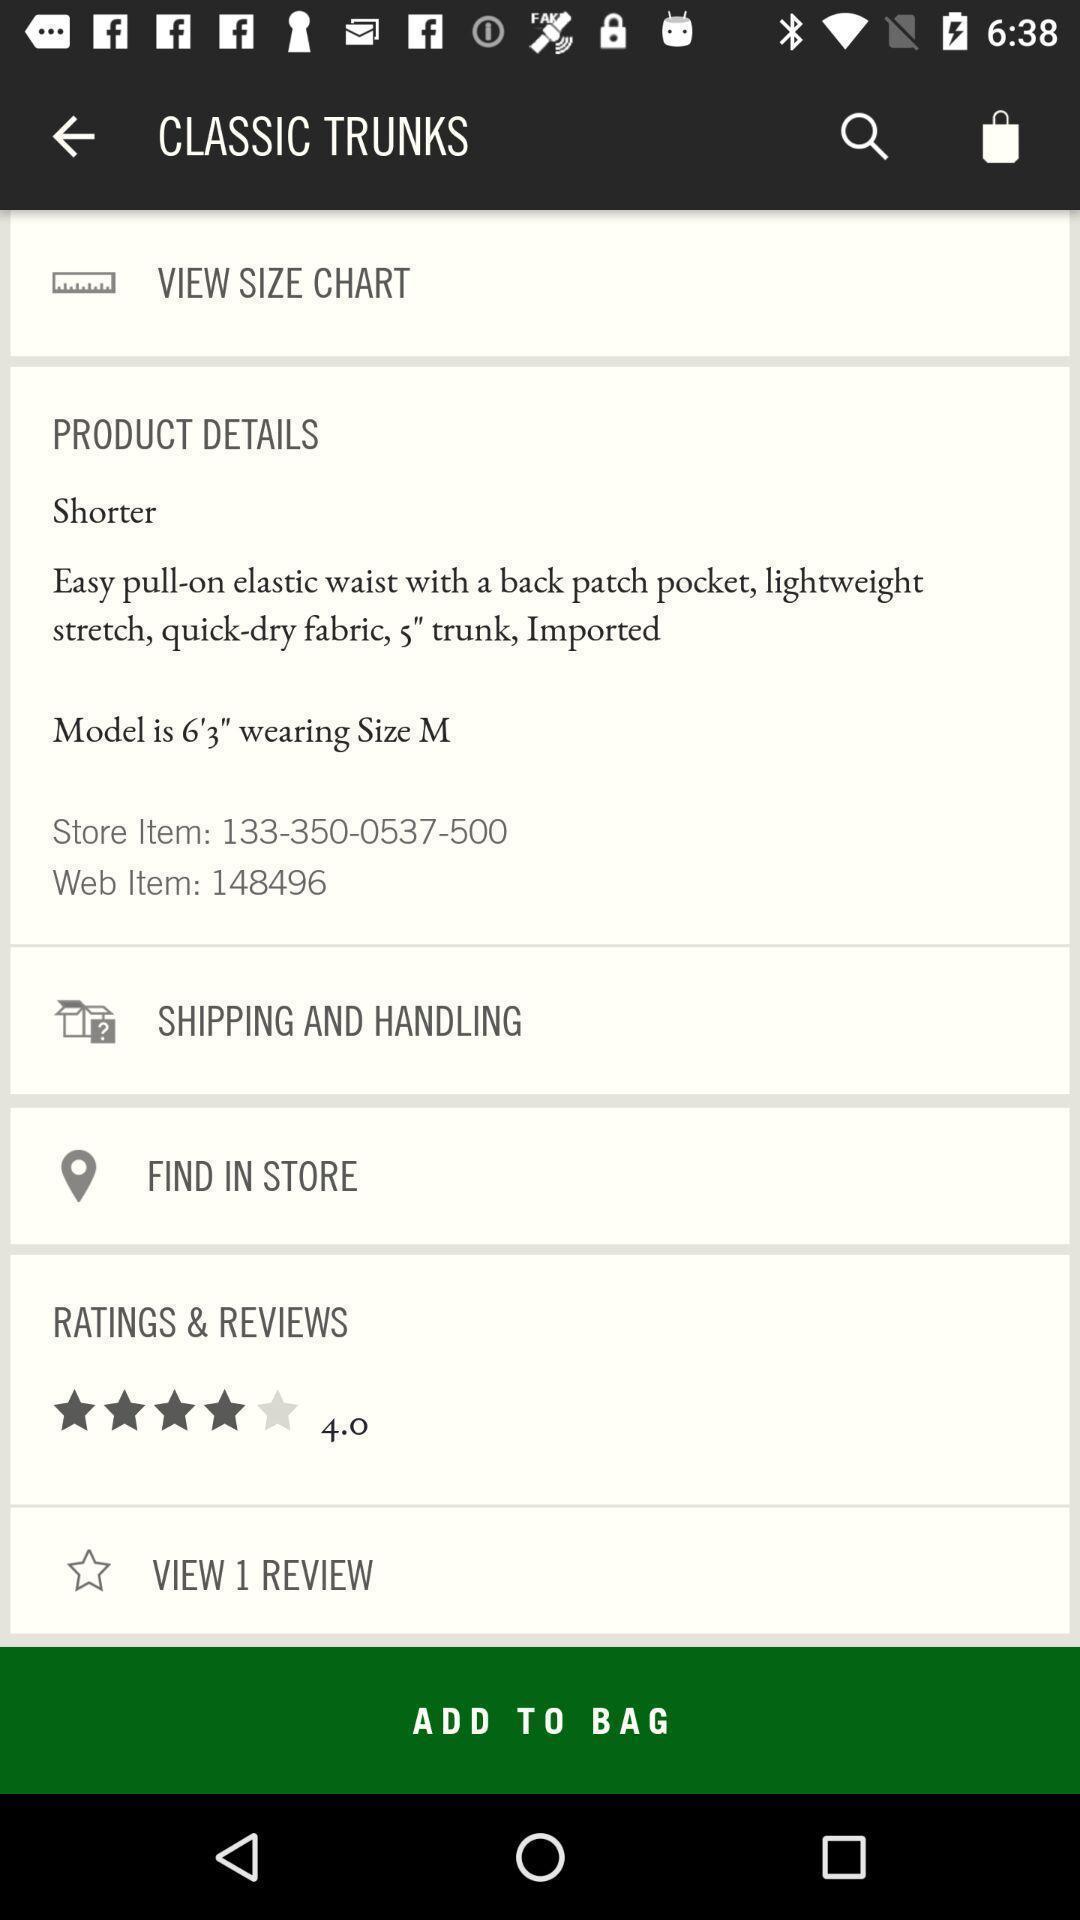Describe the content in this image. Page displaying various options of a product. 